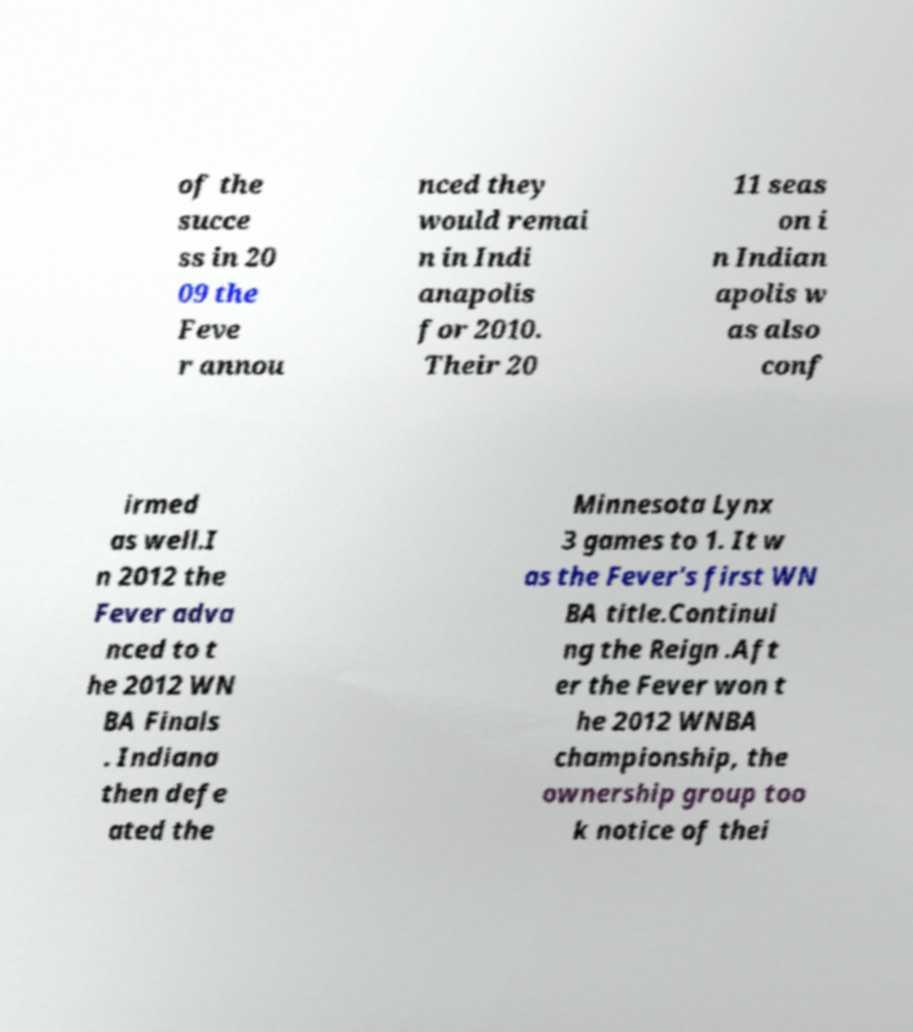I need the written content from this picture converted into text. Can you do that? of the succe ss in 20 09 the Feve r annou nced they would remai n in Indi anapolis for 2010. Their 20 11 seas on i n Indian apolis w as also conf irmed as well.I n 2012 the Fever adva nced to t he 2012 WN BA Finals . Indiana then defe ated the Minnesota Lynx 3 games to 1. It w as the Fever's first WN BA title.Continui ng the Reign .Aft er the Fever won t he 2012 WNBA championship, the ownership group too k notice of thei 